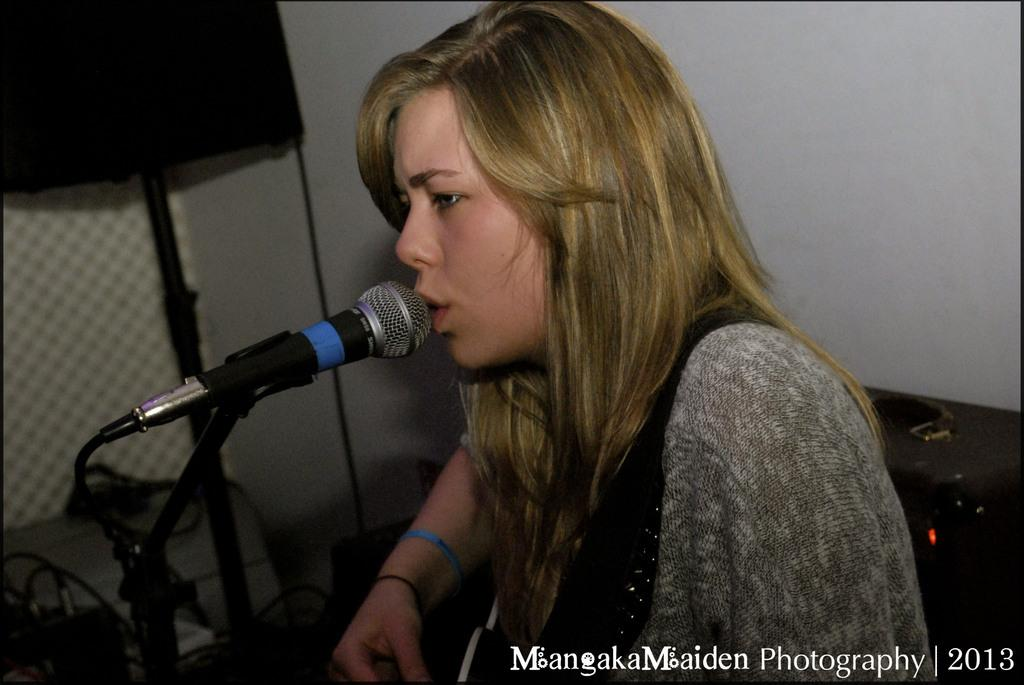What is the lady in the image doing? The lady in the image is sitting and singing. What is placed in front of the lady? A microphone is placed before the lady. What can be seen in the background of the image? There is a speaker and a wall in the background of the image. What type of test can be seen being conducted in the image? There is no test being conducted in the image; it features a lady singing with a microphone. What is the direction of the zephyr in the image? There is no mention of a zephyr or any wind in the image; it is focused on the lady singing. 